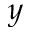Convert formula to latex. <formula><loc_0><loc_0><loc_500><loc_500>y</formula> 